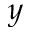Convert formula to latex. <formula><loc_0><loc_0><loc_500><loc_500>y</formula> 